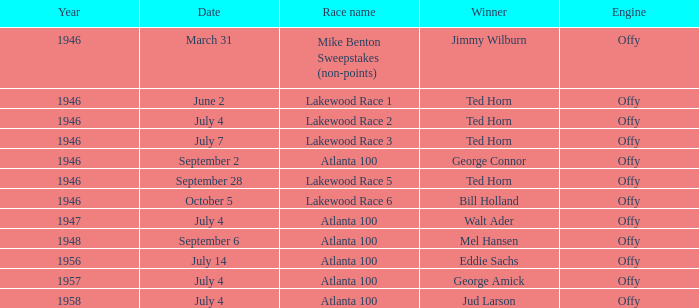In 1946, which contest did bill holland achieve victory in? Lakewood Race 6. Would you be able to parse every entry in this table? {'header': ['Year', 'Date', 'Race name', 'Winner', 'Engine'], 'rows': [['1946', 'March 31', 'Mike Benton Sweepstakes (non-points)', 'Jimmy Wilburn', 'Offy'], ['1946', 'June 2', 'Lakewood Race 1', 'Ted Horn', 'Offy'], ['1946', 'July 4', 'Lakewood Race 2', 'Ted Horn', 'Offy'], ['1946', 'July 7', 'Lakewood Race 3', 'Ted Horn', 'Offy'], ['1946', 'September 2', 'Atlanta 100', 'George Connor', 'Offy'], ['1946', 'September 28', 'Lakewood Race 5', 'Ted Horn', 'Offy'], ['1946', 'October 5', 'Lakewood Race 6', 'Bill Holland', 'Offy'], ['1947', 'July 4', 'Atlanta 100', 'Walt Ader', 'Offy'], ['1948', 'September 6', 'Atlanta 100', 'Mel Hansen', 'Offy'], ['1956', 'July 14', 'Atlanta 100', 'Eddie Sachs', 'Offy'], ['1957', 'July 4', 'Atlanta 100', 'George Amick', 'Offy'], ['1958', 'July 4', 'Atlanta 100', 'Jud Larson', 'Offy']]} 